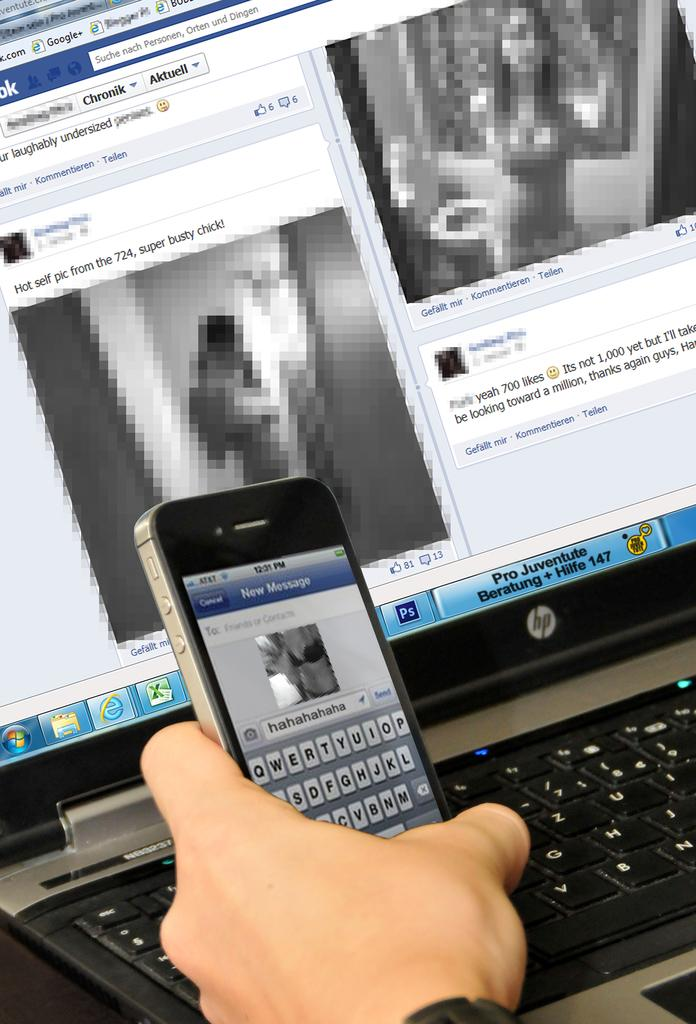What is being held by the hand in the image? There is a hand holding a mobile in the image. What electronic device can be seen in the image besides the mobile? There is a laptop in the image. What type of rabbit is playing the instrument at the club in the image? There is no rabbit, club, or instrument present in the image. 